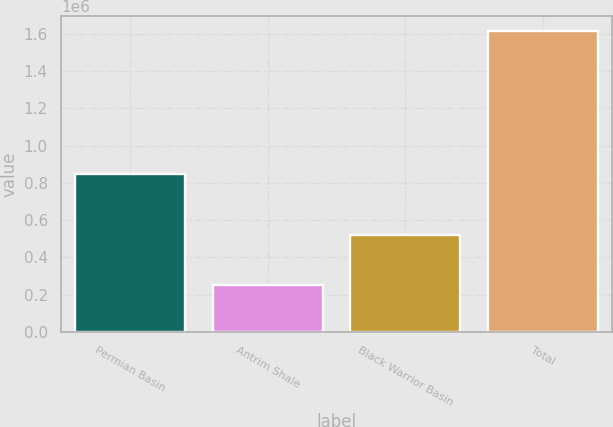<chart> <loc_0><loc_0><loc_500><loc_500><bar_chart><fcel>Permian Basin<fcel>Antrim Shale<fcel>Black Warrior Basin<fcel>Total<nl><fcel>845228<fcel>252592<fcel>517202<fcel>1.61502e+06<nl></chart> 